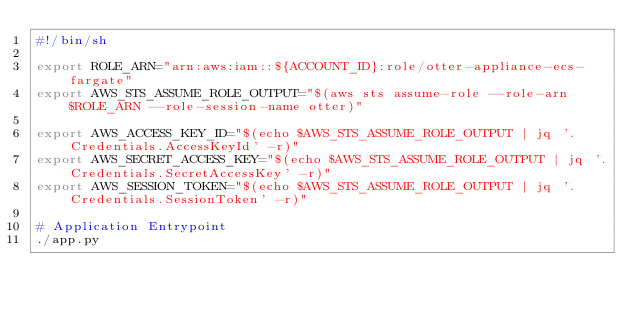<code> <loc_0><loc_0><loc_500><loc_500><_Bash_>#!/bin/sh

export ROLE_ARN="arn:aws:iam::${ACCOUNT_ID}:role/otter-appliance-ecs-fargate"
export AWS_STS_ASSUME_ROLE_OUTPUT="$(aws sts assume-role --role-arn $ROLE_ARN --role-session-name otter)"

export AWS_ACCESS_KEY_ID="$(echo $AWS_STS_ASSUME_ROLE_OUTPUT | jq '.Credentials.AccessKeyId' -r)"
export AWS_SECRET_ACCESS_KEY="$(echo $AWS_STS_ASSUME_ROLE_OUTPUT | jq '.Credentials.SecretAccessKey' -r)"
export AWS_SESSION_TOKEN="$(echo $AWS_STS_ASSUME_ROLE_OUTPUT | jq '.Credentials.SessionToken' -r)"

# Application Entrypoint
./app.py
</code> 